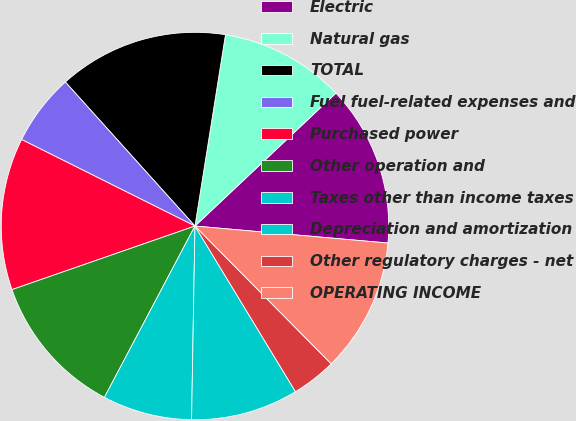Convert chart. <chart><loc_0><loc_0><loc_500><loc_500><pie_chart><fcel>Electric<fcel>Natural gas<fcel>TOTAL<fcel>Fuel fuel-related expenses and<fcel>Purchased power<fcel>Other operation and<fcel>Taxes other than income taxes<fcel>Depreciation and amortization<fcel>Other regulatory charges - net<fcel>OPERATING INCOME<nl><fcel>13.43%<fcel>10.45%<fcel>14.18%<fcel>5.97%<fcel>12.69%<fcel>11.94%<fcel>7.46%<fcel>8.96%<fcel>3.73%<fcel>11.19%<nl></chart> 